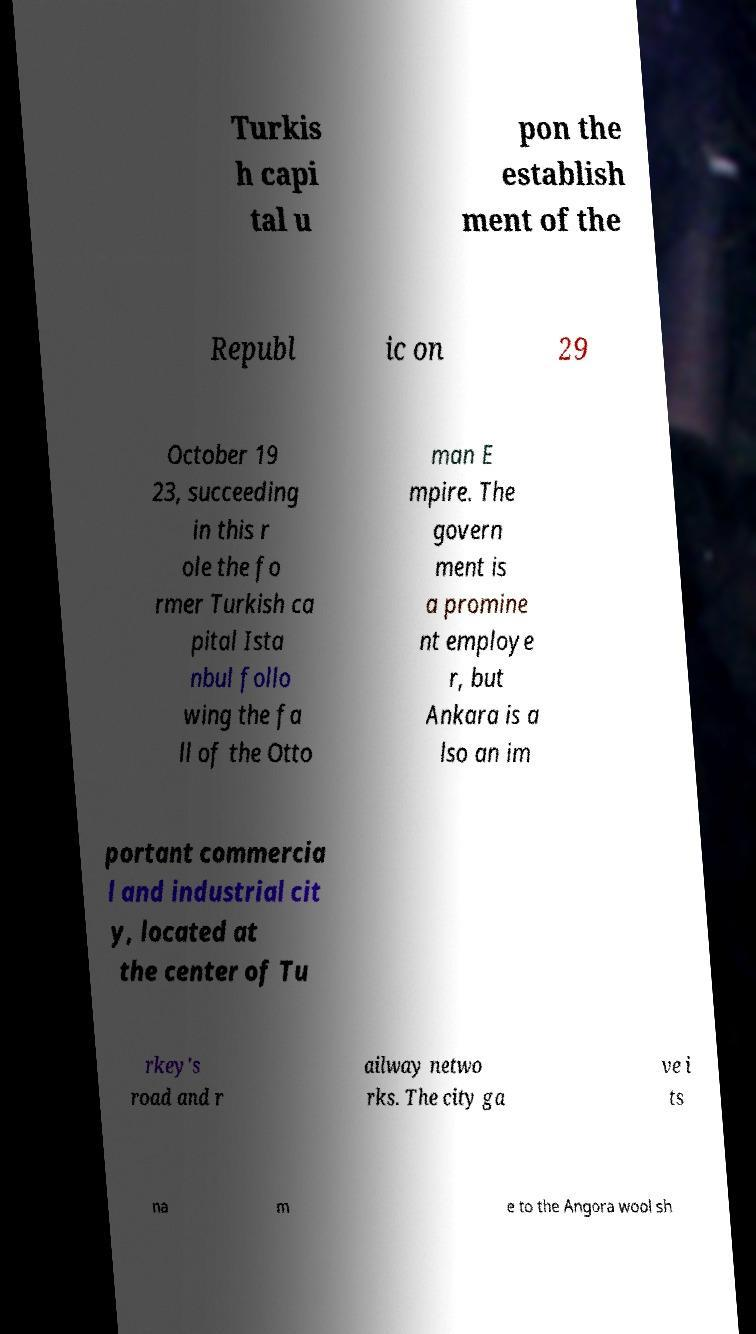For documentation purposes, I need the text within this image transcribed. Could you provide that? Turkis h capi tal u pon the establish ment of the Republ ic on 29 October 19 23, succeeding in this r ole the fo rmer Turkish ca pital Ista nbul follo wing the fa ll of the Otto man E mpire. The govern ment is a promine nt employe r, but Ankara is a lso an im portant commercia l and industrial cit y, located at the center of Tu rkey's road and r ailway netwo rks. The city ga ve i ts na m e to the Angora wool sh 